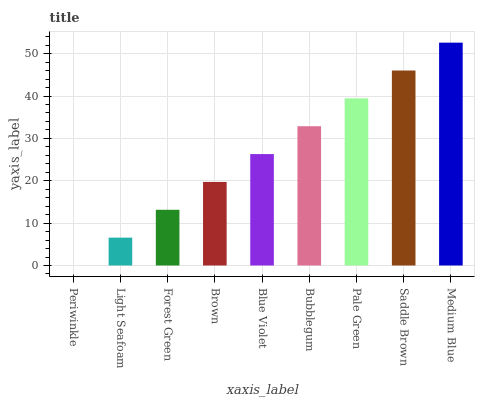Is Light Seafoam the minimum?
Answer yes or no. No. Is Light Seafoam the maximum?
Answer yes or no. No. Is Light Seafoam greater than Periwinkle?
Answer yes or no. Yes. Is Periwinkle less than Light Seafoam?
Answer yes or no. Yes. Is Periwinkle greater than Light Seafoam?
Answer yes or no. No. Is Light Seafoam less than Periwinkle?
Answer yes or no. No. Is Blue Violet the high median?
Answer yes or no. Yes. Is Blue Violet the low median?
Answer yes or no. Yes. Is Periwinkle the high median?
Answer yes or no. No. Is Brown the low median?
Answer yes or no. No. 